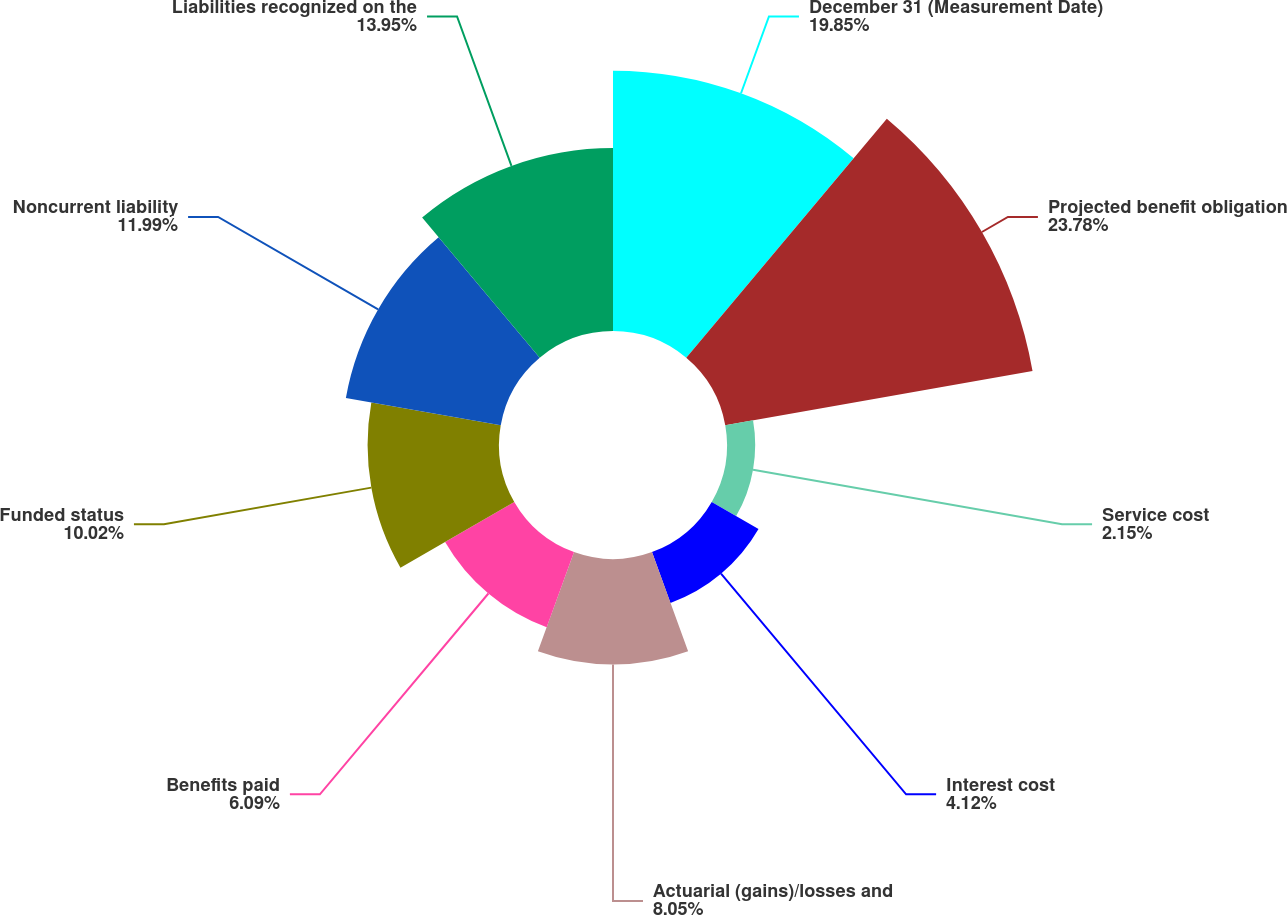Convert chart to OTSL. <chart><loc_0><loc_0><loc_500><loc_500><pie_chart><fcel>December 31 (Measurement Date)<fcel>Projected benefit obligation<fcel>Service cost<fcel>Interest cost<fcel>Actuarial (gains)/losses and<fcel>Benefits paid<fcel>Funded status<fcel>Noncurrent liability<fcel>Liabilities recognized on the<nl><fcel>19.85%<fcel>23.79%<fcel>2.15%<fcel>4.12%<fcel>8.05%<fcel>6.09%<fcel>10.02%<fcel>11.99%<fcel>13.95%<nl></chart> 